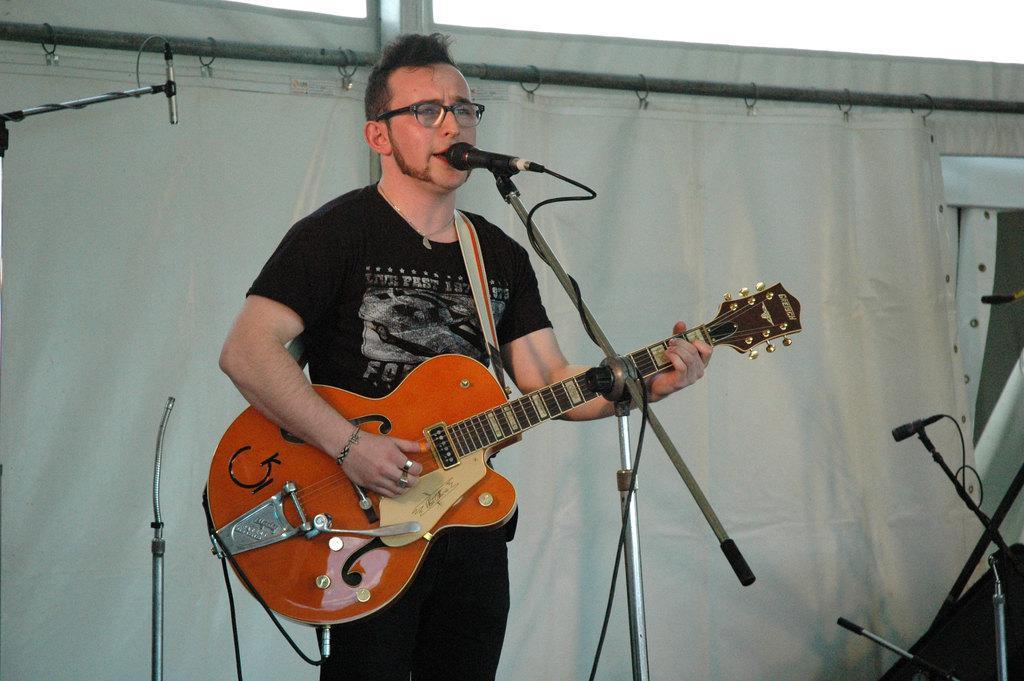Describe this image in one or two sentences. There is a person wearing a black color T-shirt playing a guitar and there is a microphone in front of him and at the background there is a white color curtain 